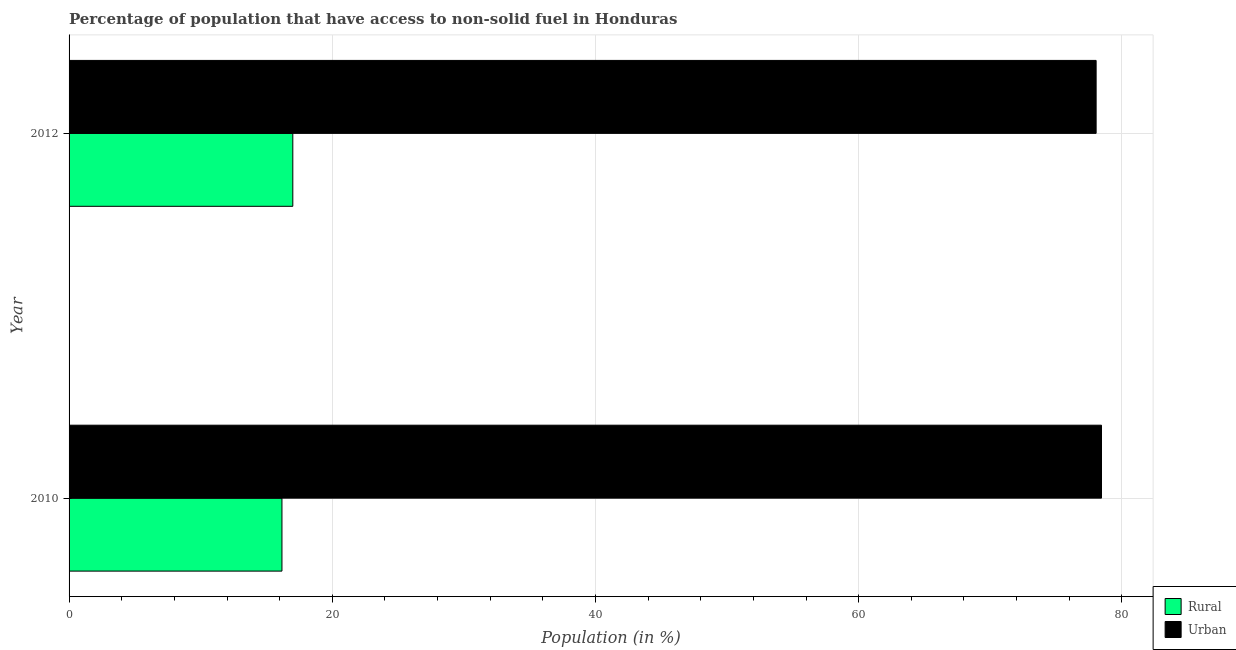How many groups of bars are there?
Provide a short and direct response. 2. Are the number of bars per tick equal to the number of legend labels?
Keep it short and to the point. Yes. Are the number of bars on each tick of the Y-axis equal?
Offer a very short reply. Yes. How many bars are there on the 1st tick from the top?
Your response must be concise. 2. How many bars are there on the 1st tick from the bottom?
Keep it short and to the point. 2. In how many cases, is the number of bars for a given year not equal to the number of legend labels?
Your answer should be compact. 0. What is the rural population in 2010?
Give a very brief answer. 16.18. Across all years, what is the maximum urban population?
Offer a terse response. 78.45. Across all years, what is the minimum urban population?
Give a very brief answer. 78.04. What is the total rural population in the graph?
Ensure brevity in your answer.  33.18. What is the difference between the rural population in 2010 and that in 2012?
Provide a short and direct response. -0.82. What is the difference between the urban population in 2010 and the rural population in 2012?
Make the answer very short. 61.45. What is the average urban population per year?
Ensure brevity in your answer.  78.25. In the year 2010, what is the difference between the rural population and urban population?
Offer a very short reply. -62.27. In how many years, is the rural population greater than 64 %?
Offer a very short reply. 0. What is the ratio of the rural population in 2010 to that in 2012?
Keep it short and to the point. 0.95. Is the difference between the urban population in 2010 and 2012 greater than the difference between the rural population in 2010 and 2012?
Provide a succinct answer. Yes. What does the 2nd bar from the top in 2010 represents?
Offer a very short reply. Rural. What does the 1st bar from the bottom in 2010 represents?
Offer a very short reply. Rural. How many bars are there?
Your response must be concise. 4. What is the difference between two consecutive major ticks on the X-axis?
Your answer should be compact. 20. What is the title of the graph?
Make the answer very short. Percentage of population that have access to non-solid fuel in Honduras. Does "Female entrants" appear as one of the legend labels in the graph?
Make the answer very short. No. What is the label or title of the X-axis?
Make the answer very short. Population (in %). What is the label or title of the Y-axis?
Your answer should be very brief. Year. What is the Population (in %) in Rural in 2010?
Your answer should be very brief. 16.18. What is the Population (in %) of Urban in 2010?
Your answer should be compact. 78.45. What is the Population (in %) in Rural in 2012?
Your answer should be compact. 17. What is the Population (in %) of Urban in 2012?
Your answer should be very brief. 78.04. Across all years, what is the maximum Population (in %) in Rural?
Ensure brevity in your answer.  17. Across all years, what is the maximum Population (in %) of Urban?
Offer a very short reply. 78.45. Across all years, what is the minimum Population (in %) in Rural?
Your response must be concise. 16.18. Across all years, what is the minimum Population (in %) in Urban?
Offer a very short reply. 78.04. What is the total Population (in %) of Rural in the graph?
Offer a terse response. 33.18. What is the total Population (in %) of Urban in the graph?
Your response must be concise. 156.49. What is the difference between the Population (in %) of Rural in 2010 and that in 2012?
Your response must be concise. -0.82. What is the difference between the Population (in %) of Urban in 2010 and that in 2012?
Your answer should be very brief. 0.41. What is the difference between the Population (in %) in Rural in 2010 and the Population (in %) in Urban in 2012?
Offer a very short reply. -61.87. What is the average Population (in %) in Rural per year?
Give a very brief answer. 16.59. What is the average Population (in %) in Urban per year?
Keep it short and to the point. 78.25. In the year 2010, what is the difference between the Population (in %) of Rural and Population (in %) of Urban?
Make the answer very short. -62.27. In the year 2012, what is the difference between the Population (in %) in Rural and Population (in %) in Urban?
Ensure brevity in your answer.  -61.04. What is the ratio of the Population (in %) of Rural in 2010 to that in 2012?
Keep it short and to the point. 0.95. What is the ratio of the Population (in %) of Urban in 2010 to that in 2012?
Make the answer very short. 1.01. What is the difference between the highest and the second highest Population (in %) of Rural?
Offer a very short reply. 0.82. What is the difference between the highest and the second highest Population (in %) in Urban?
Your response must be concise. 0.41. What is the difference between the highest and the lowest Population (in %) of Rural?
Offer a terse response. 0.82. What is the difference between the highest and the lowest Population (in %) of Urban?
Make the answer very short. 0.41. 